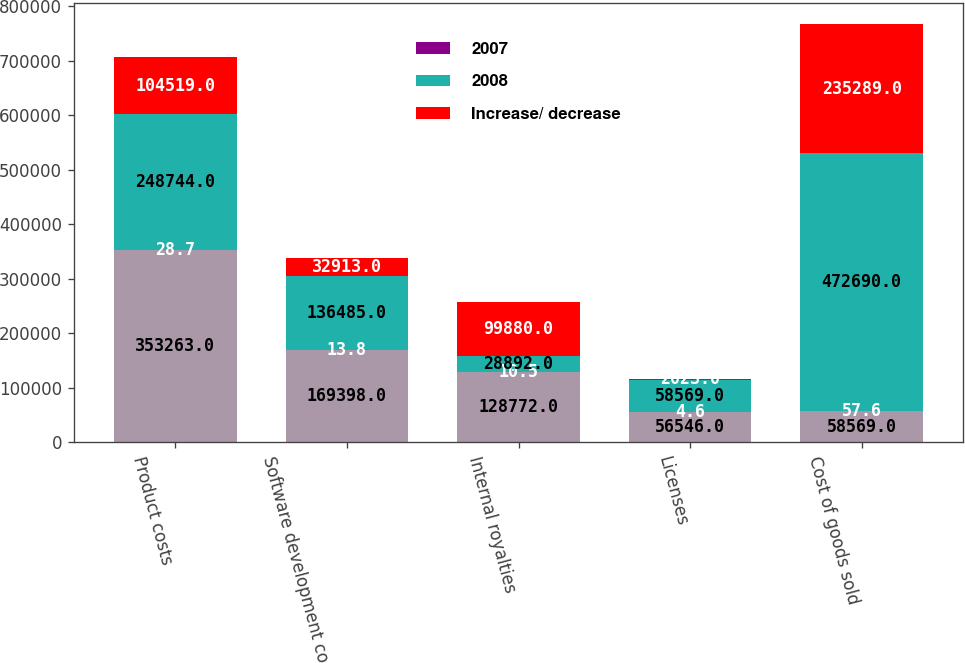Convert chart. <chart><loc_0><loc_0><loc_500><loc_500><stacked_bar_chart><ecel><fcel>Product costs<fcel>Software development costs and<fcel>Internal royalties<fcel>Licenses<fcel>Cost of goods sold<nl><fcel>nan<fcel>353263<fcel>169398<fcel>128772<fcel>56546<fcel>58569<nl><fcel>2007<fcel>28.7<fcel>13.8<fcel>10.5<fcel>4.6<fcel>57.6<nl><fcel>2008<fcel>248744<fcel>136485<fcel>28892<fcel>58569<fcel>472690<nl><fcel>Increase/ decrease<fcel>104519<fcel>32913<fcel>99880<fcel>2023<fcel>235289<nl></chart> 